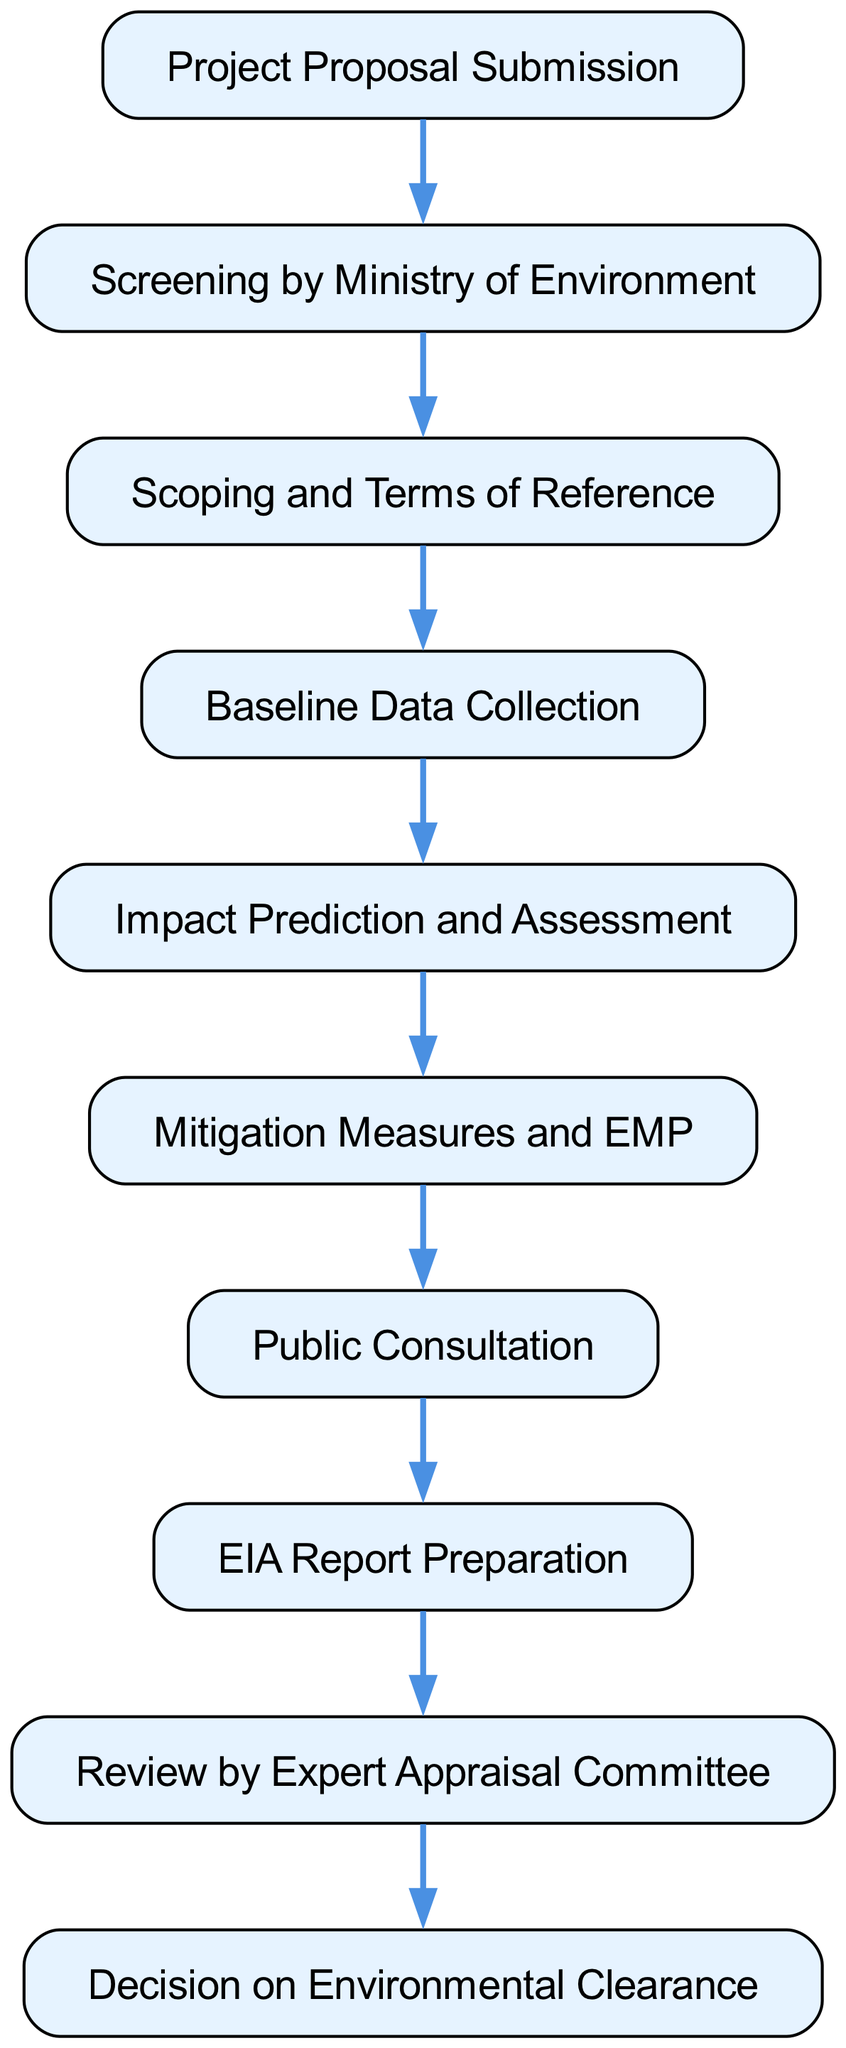What is the first step in the process? The diagram indicates that the first step in the process of conducting an environmental impact assessment is "Project Proposal Submission."
Answer: Project Proposal Submission How many steps are there in total? By counting the nodes in the diagram, it is confirmed that there are ten distinct steps from project proposal to decision on environmental clearance.
Answer: Ten What follows after "Public Consultation"? The diagram shows that after "Public Consultation," the next step is "EIA Report Preparation."
Answer: EIA Report Preparation Which step includes the review of the project? The "Review by Expert Appraisal Committee" is specifically designed for the assessment and evaluation of the project.
Answer: Review by Expert Appraisal Committee What is the last step of the process? The final step in the flow chart is "Decision on Environmental Clearance," which concludes the assessment process.
Answer: Decision on Environmental Clearance What is needed before starting the "Impact Prediction and Assessment"? Prior to "Impact Prediction and Assessment," the step "Baseline Data Collection" must be completed to gather necessary data.
Answer: Baseline Data Collection Which two steps directly precede the "EIA Report Preparation"? The two steps directly before "EIA Report Preparation" are "Public Consultation" and "Mitigation Measures and EMP."
Answer: Public Consultation and Mitigation Measures and EMP Which step follows the "Scoping and Terms of Reference"? After "Scoping and Terms of Reference," the next step is "Baseline Data Collection," indicating a progression in gathering initial data.
Answer: Baseline Data Collection What is the relationship between "Impact Prediction and Assessment" and "Mitigation Measures and EMP"? "Impact Prediction and Assessment" must occur before the "Mitigation Measures and EMP" step, as it relies on the outcomes of the assessment to implement mitigation strategies.
Answer: Sequential relationship 